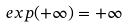<formula> <loc_0><loc_0><loc_500><loc_500>e x p ( + \infty ) = + \infty</formula> 